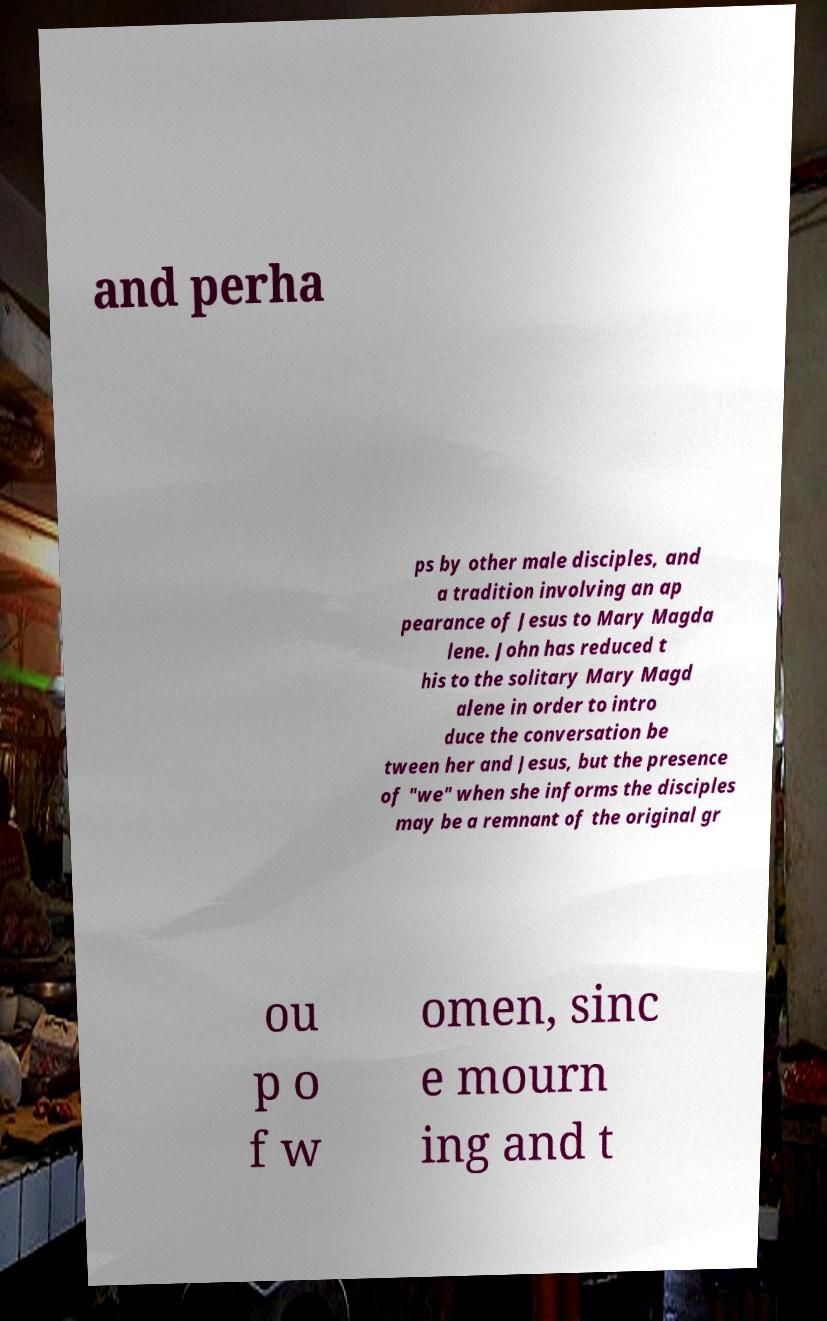Can you read and provide the text displayed in the image?This photo seems to have some interesting text. Can you extract and type it out for me? and perha ps by other male disciples, and a tradition involving an ap pearance of Jesus to Mary Magda lene. John has reduced t his to the solitary Mary Magd alene in order to intro duce the conversation be tween her and Jesus, but the presence of "we" when she informs the disciples may be a remnant of the original gr ou p o f w omen, sinc e mourn ing and t 